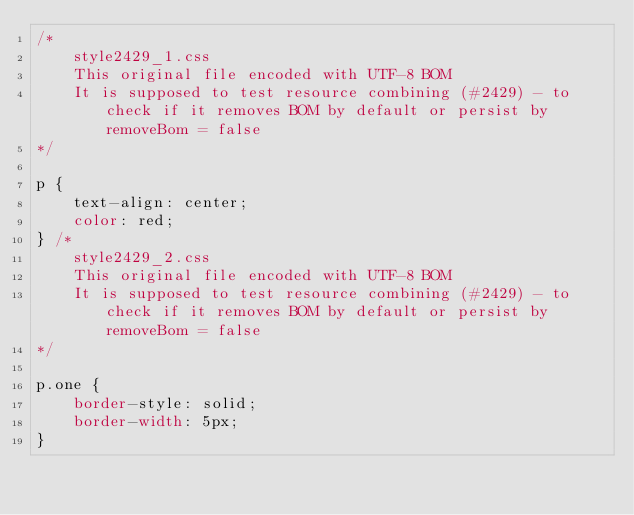Convert code to text. <code><loc_0><loc_0><loc_500><loc_500><_CSS_>/*
    style2429_1.css
    This original file encoded with UTF-8 BOM
    It is supposed to test resource combining (#2429) - to check if it removes BOM by default or persist by removeBom = false
*/

p {
    text-align: center;
    color: red;
} /*
    style2429_2.css
    This original file encoded with UTF-8 BOM
    It is supposed to test resource combining (#2429) - to check if it removes BOM by default or persist by removeBom = false
*/

p.one {
    border-style: solid;
    border-width: 5px;
}</code> 